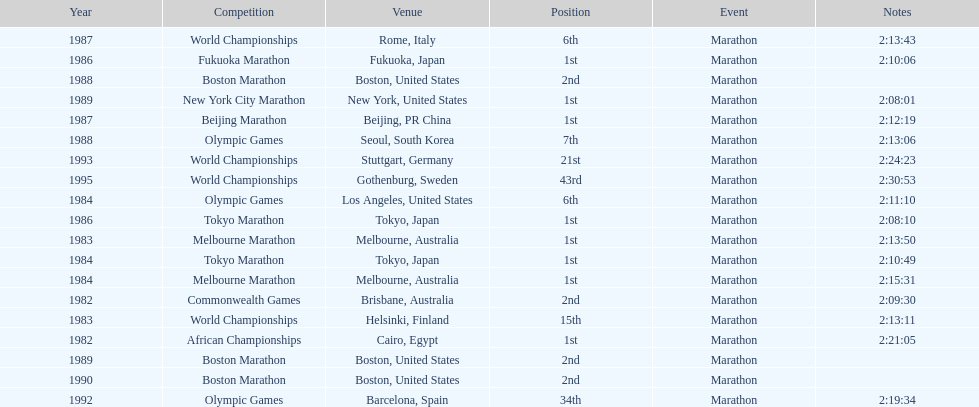Write the full table. {'header': ['Year', 'Competition', 'Venue', 'Position', 'Event', 'Notes'], 'rows': [['1987', 'World Championships', 'Rome, Italy', '6th', 'Marathon', '2:13:43'], ['1986', 'Fukuoka Marathon', 'Fukuoka, Japan', '1st', 'Marathon', '2:10:06'], ['1988', 'Boston Marathon', 'Boston, United States', '2nd', 'Marathon', ''], ['1989', 'New York City Marathon', 'New York, United States', '1st', 'Marathon', '2:08:01'], ['1987', 'Beijing Marathon', 'Beijing, PR China', '1st', 'Marathon', '2:12:19'], ['1988', 'Olympic Games', 'Seoul, South Korea', '7th', 'Marathon', '2:13:06'], ['1993', 'World Championships', 'Stuttgart, Germany', '21st', 'Marathon', '2:24:23'], ['1995', 'World Championships', 'Gothenburg, Sweden', '43rd', 'Marathon', '2:30:53'], ['1984', 'Olympic Games', 'Los Angeles, United States', '6th', 'Marathon', '2:11:10'], ['1986', 'Tokyo Marathon', 'Tokyo, Japan', '1st', 'Marathon', '2:08:10'], ['1983', 'Melbourne Marathon', 'Melbourne, Australia', '1st', 'Marathon', '2:13:50'], ['1984', 'Tokyo Marathon', 'Tokyo, Japan', '1st', 'Marathon', '2:10:49'], ['1984', 'Melbourne Marathon', 'Melbourne, Australia', '1st', 'Marathon', '2:15:31'], ['1982', 'Commonwealth Games', 'Brisbane, Australia', '2nd', 'Marathon', '2:09:30'], ['1983', 'World Championships', 'Helsinki, Finland', '15th', 'Marathon', '2:13:11'], ['1982', 'African Championships', 'Cairo, Egypt', '1st', 'Marathon', '2:21:05'], ['1989', 'Boston Marathon', 'Boston, United States', '2nd', 'Marathon', ''], ['1990', 'Boston Marathon', 'Boston, United States', '2nd', 'Marathon', ''], ['1992', 'Olympic Games', 'Barcelona, Spain', '34th', 'Marathon', '2:19:34']]} What are all the competitions? African Championships, Commonwealth Games, World Championships, Melbourne Marathon, Tokyo Marathon, Olympic Games, Melbourne Marathon, Tokyo Marathon, Fukuoka Marathon, World Championships, Beijing Marathon, Olympic Games, Boston Marathon, New York City Marathon, Boston Marathon, Boston Marathon, Olympic Games, World Championships, World Championships. Where were they located? Cairo, Egypt, Brisbane, Australia, Helsinki, Finland, Melbourne, Australia, Tokyo, Japan, Los Angeles, United States, Melbourne, Australia, Tokyo, Japan, Fukuoka, Japan, Rome, Italy, Beijing, PR China, Seoul, South Korea, Boston, United States, New York, United States, Boston, United States, Boston, United States, Barcelona, Spain, Stuttgart, Germany, Gothenburg, Sweden. And which competition was in china? Beijing Marathon. 